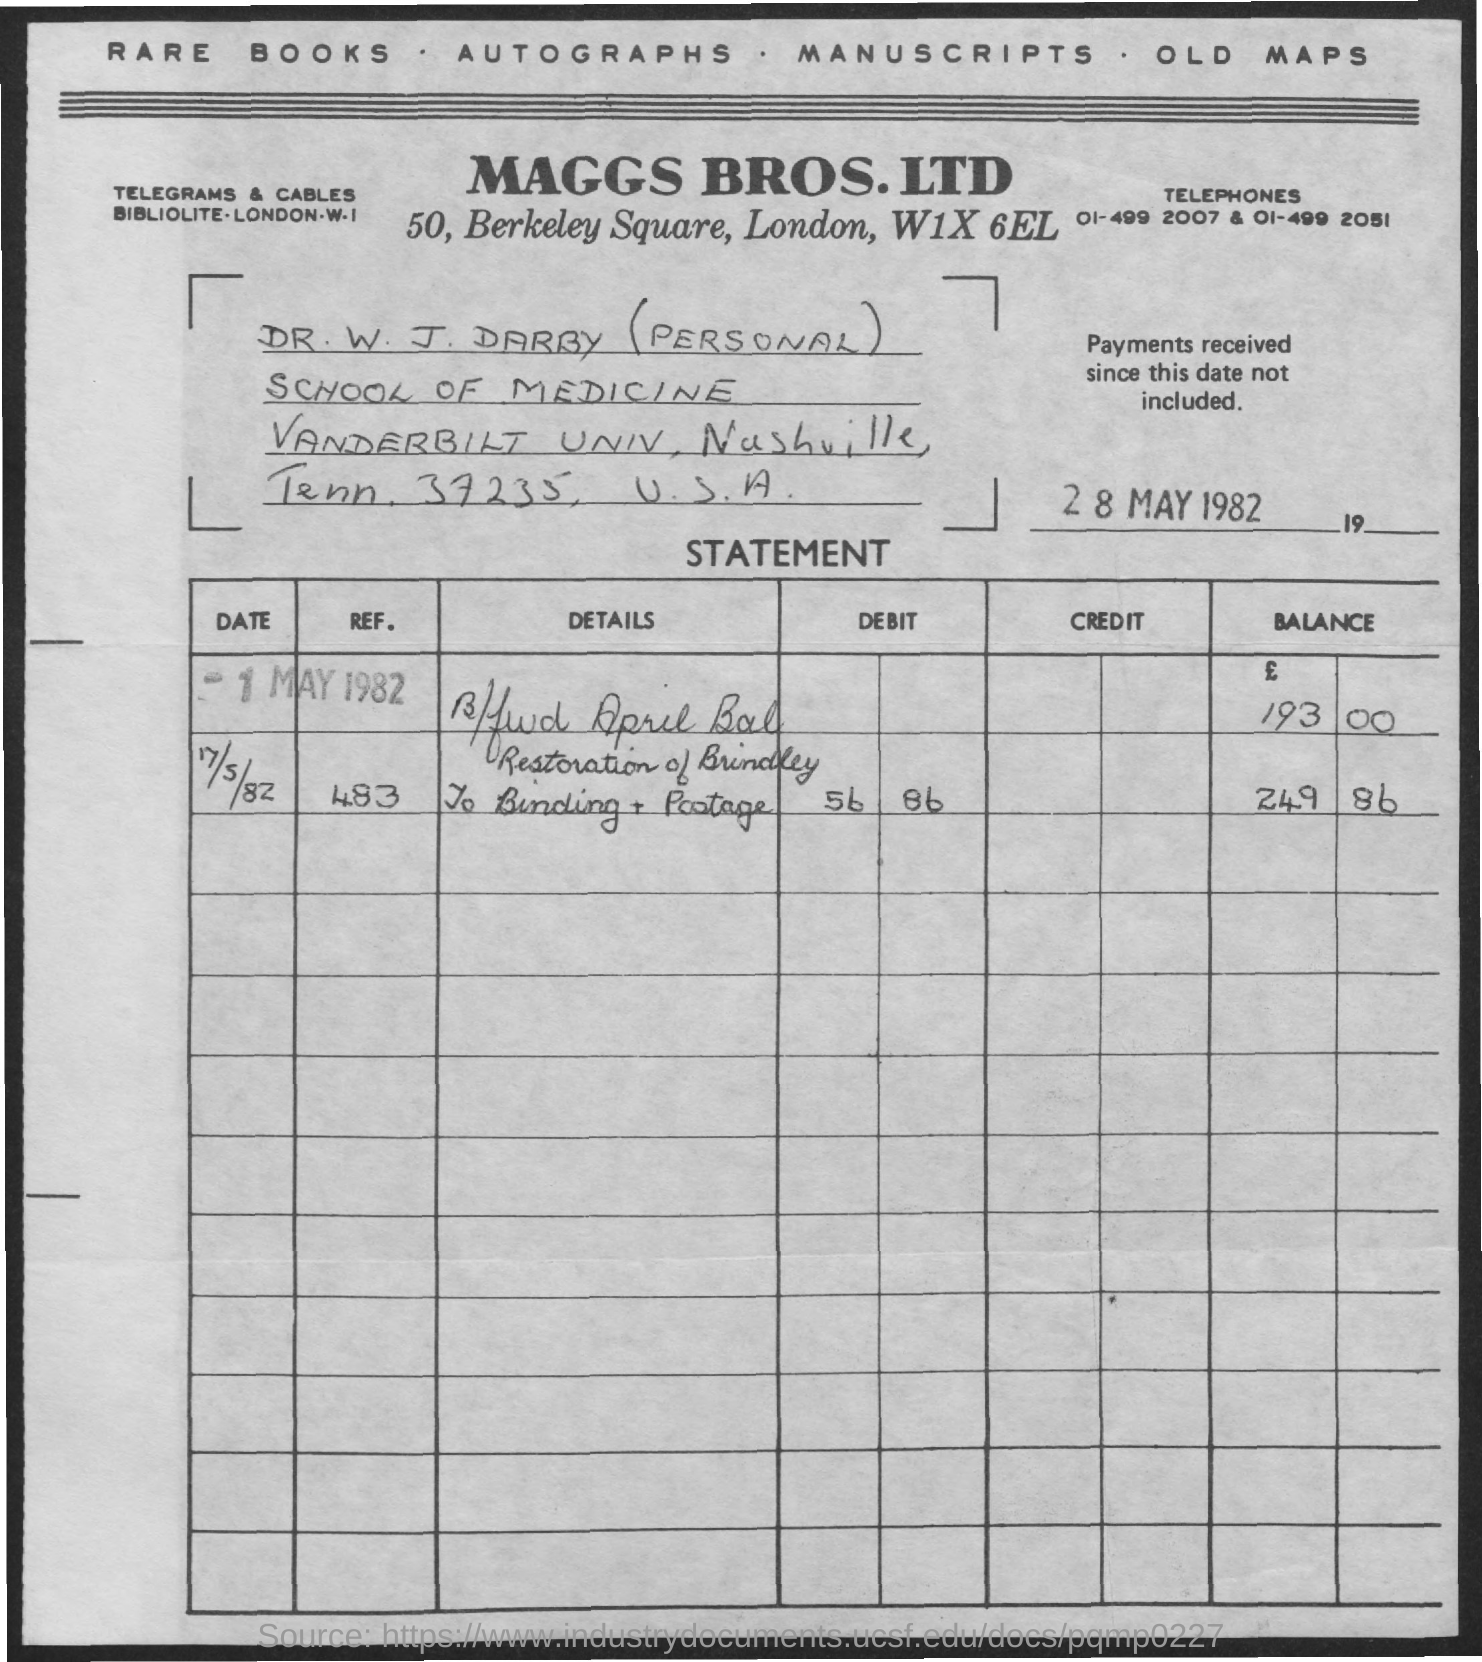When is the document dated?
Your response must be concise. 28 may 1982. In which city is  MAGGS BROS. LTD located?
Make the answer very short. London. 